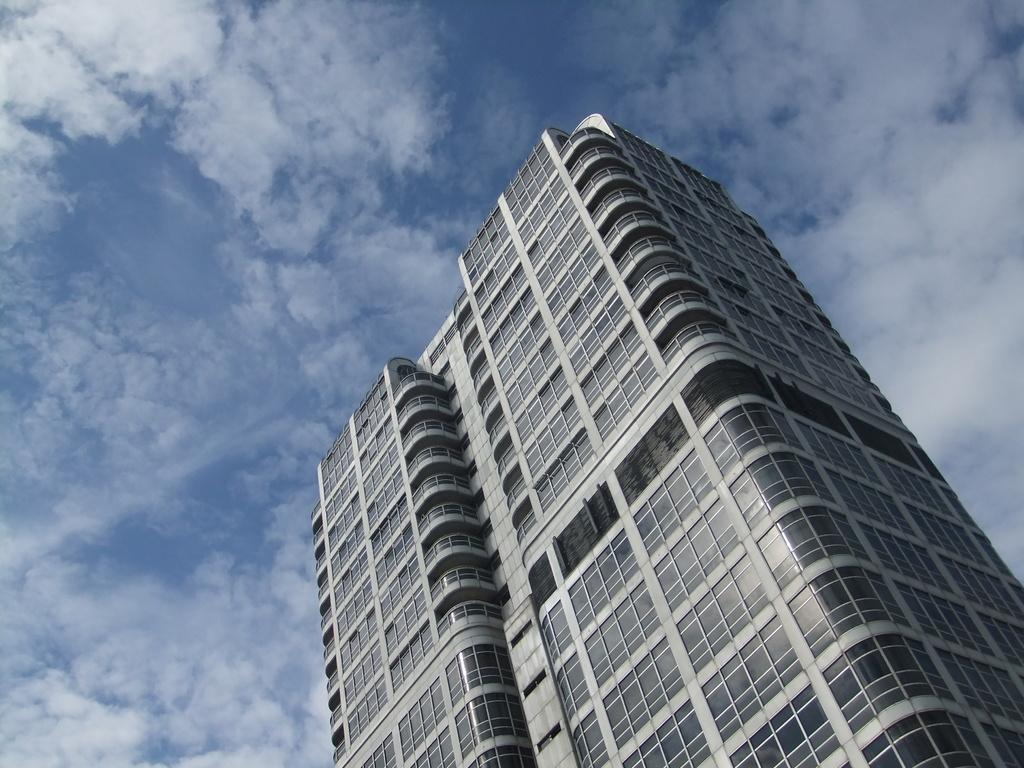What type of structure is the main subject of the image? There is a tower building in the picture. What material is used for the tower building's exterior? The tower building has glass. What can be seen in the background of the image? There is a sky visible in the background of the image. What is the weather like in the image? Clouds are present in the sky, suggesting partly cloudy weather. What type of cakes is the father holding in the image? There is no father or cakes present in the image; it features a tower building with glass and a sky with clouds. 